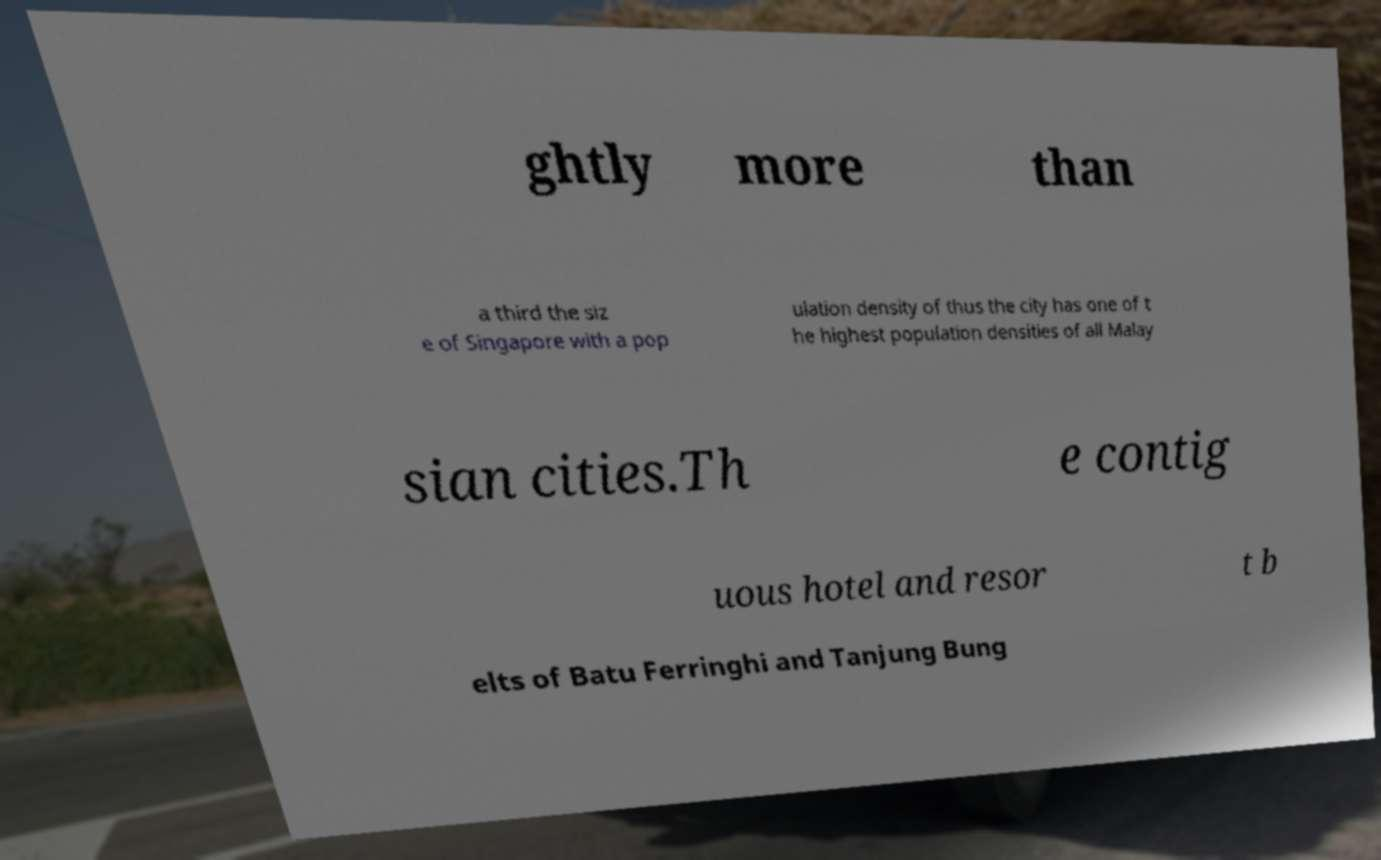Please read and relay the text visible in this image. What does it say? ghtly more than a third the siz e of Singapore with a pop ulation density of thus the city has one of t he highest population densities of all Malay sian cities.Th e contig uous hotel and resor t b elts of Batu Ferringhi and Tanjung Bung 